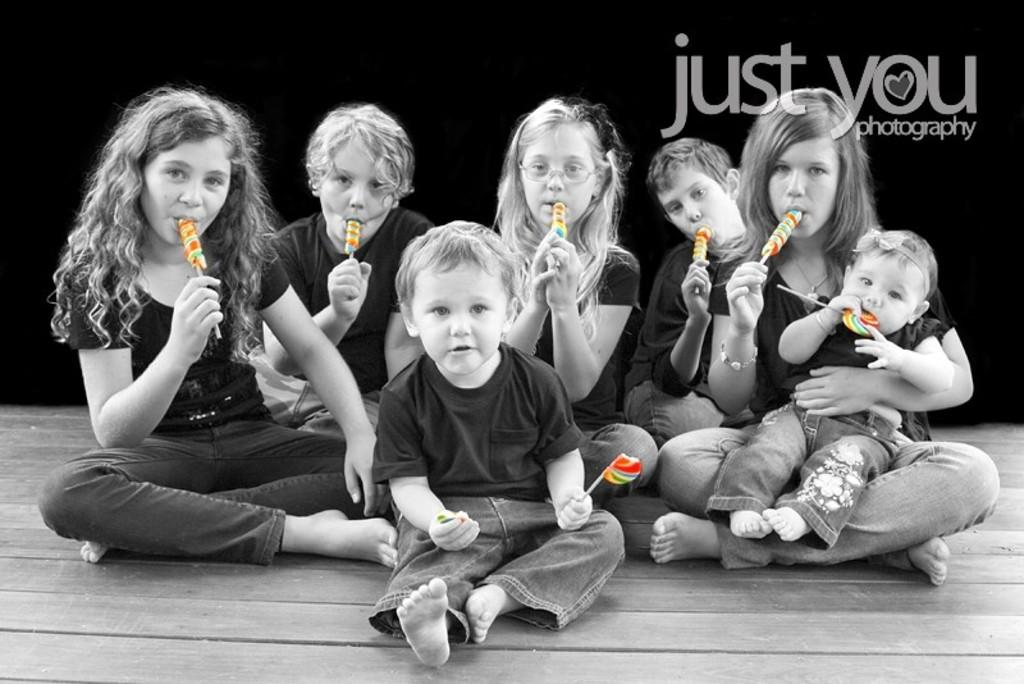How many people are in the image? There is a group of people in the image. What are the people wearing? The people are wearing black t-shirts. What are the people holding in the image? The people are holding lollipops. What else can be seen in the image besides the people? There is a banner visible in the image. What type of drum is being played by the people in the image? There is no drum present in the image; the people are holding lollipops. 